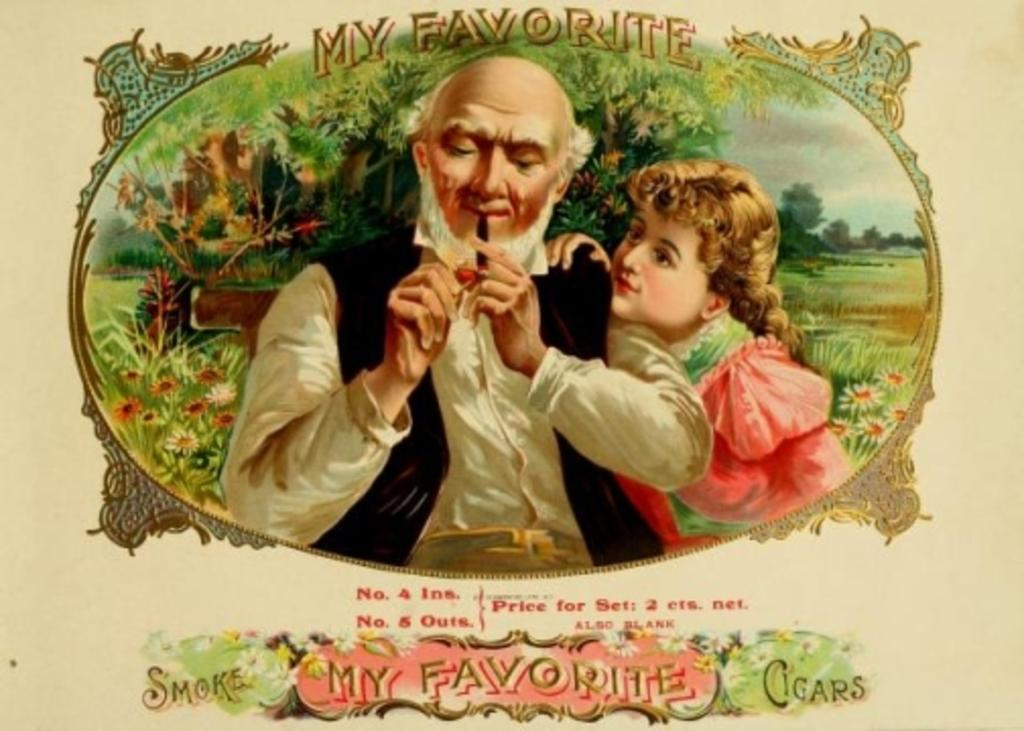<image>
Relay a brief, clear account of the picture shown. an old man smoking a tobacco pipe with the words 'my favorite' above him 